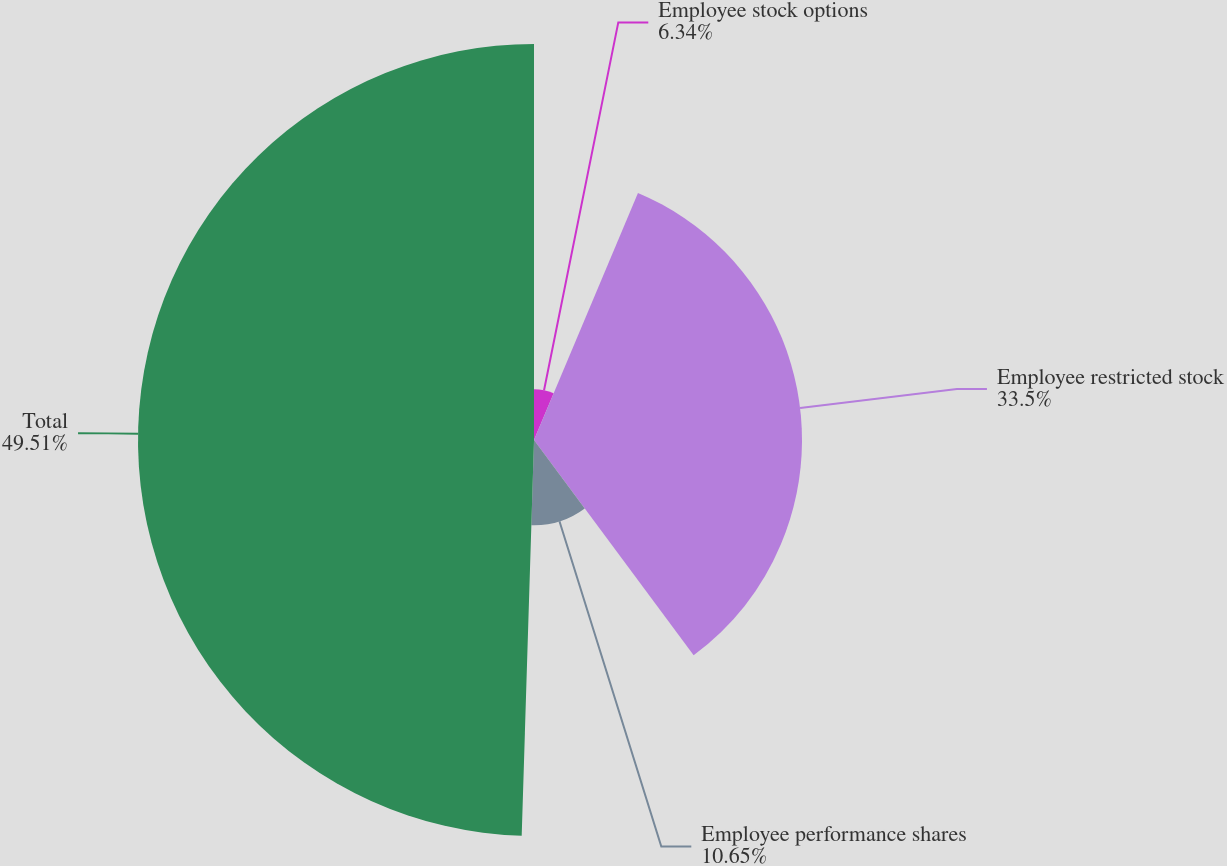Convert chart to OTSL. <chart><loc_0><loc_0><loc_500><loc_500><pie_chart><fcel>Employee stock options<fcel>Employee restricted stock<fcel>Employee performance shares<fcel>Total<nl><fcel>6.34%<fcel>33.5%<fcel>10.65%<fcel>49.5%<nl></chart> 